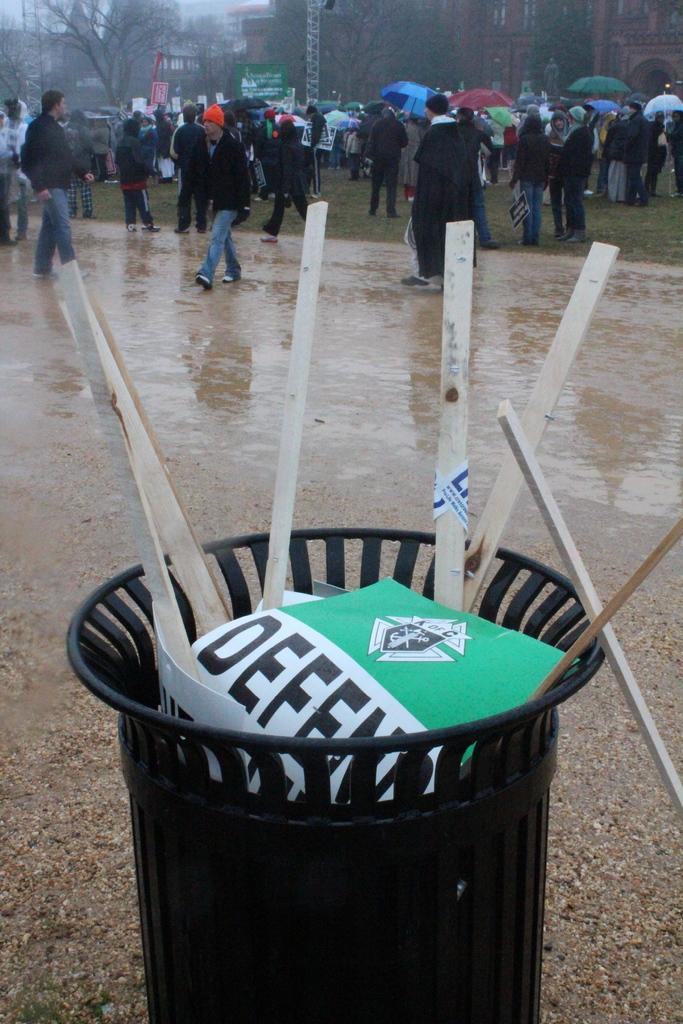<image>
Describe the image concisely. A green Defend sign fills the trash while people stand in the rain nearby. 